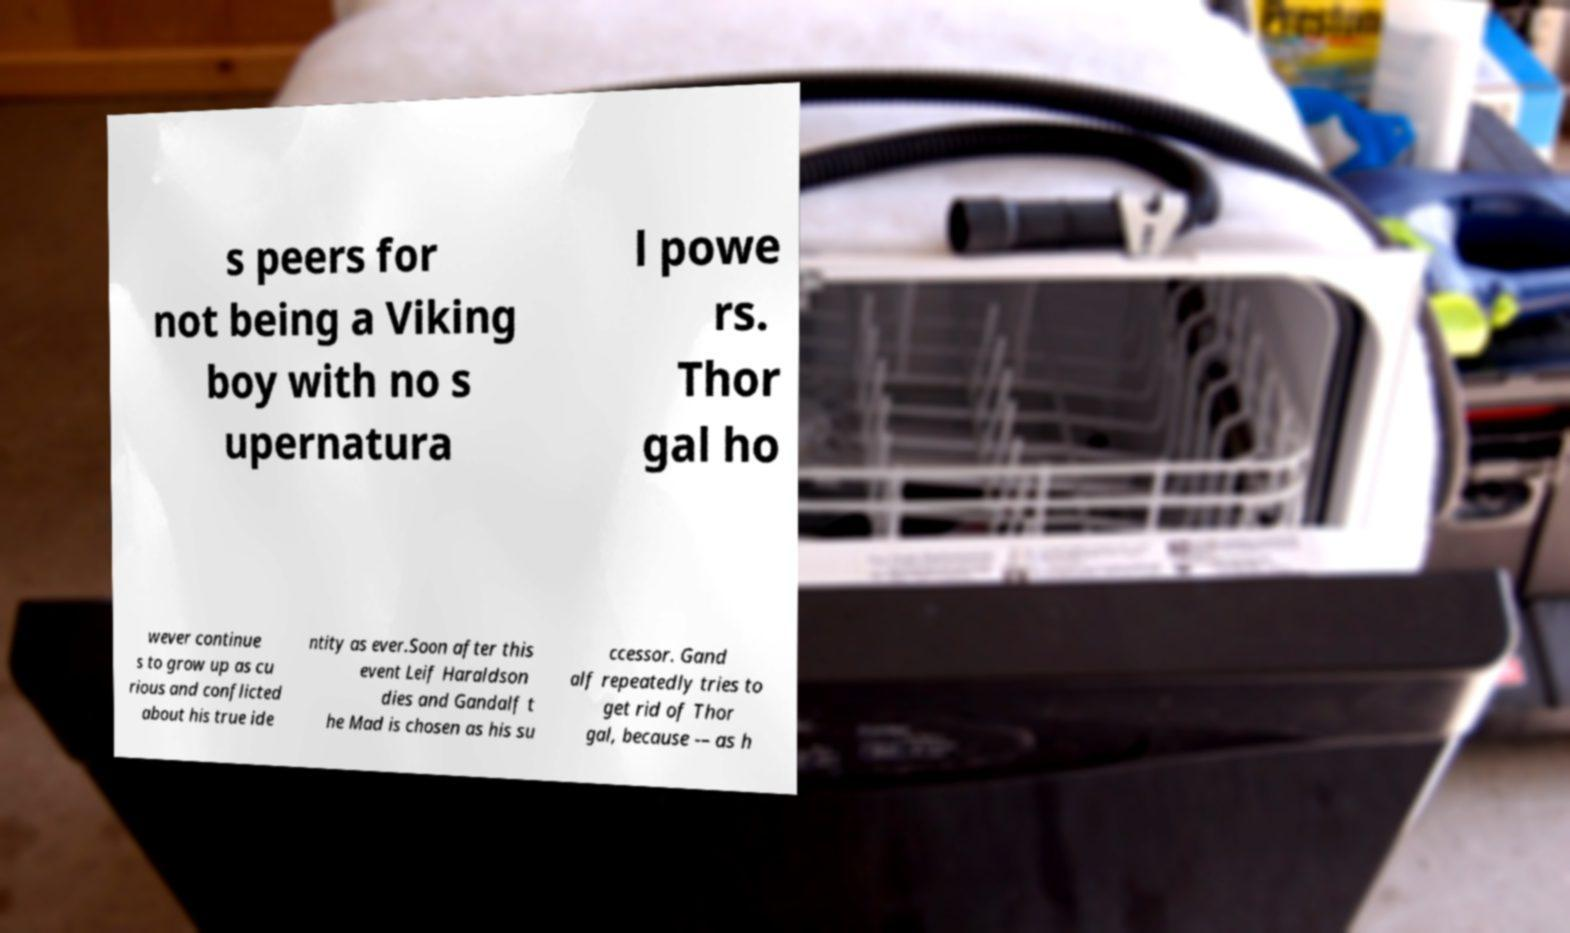I need the written content from this picture converted into text. Can you do that? s peers for not being a Viking boy with no s upernatura l powe rs. Thor gal ho wever continue s to grow up as cu rious and conflicted about his true ide ntity as ever.Soon after this event Leif Haraldson dies and Gandalf t he Mad is chosen as his su ccessor. Gand alf repeatedly tries to get rid of Thor gal, because -– as h 